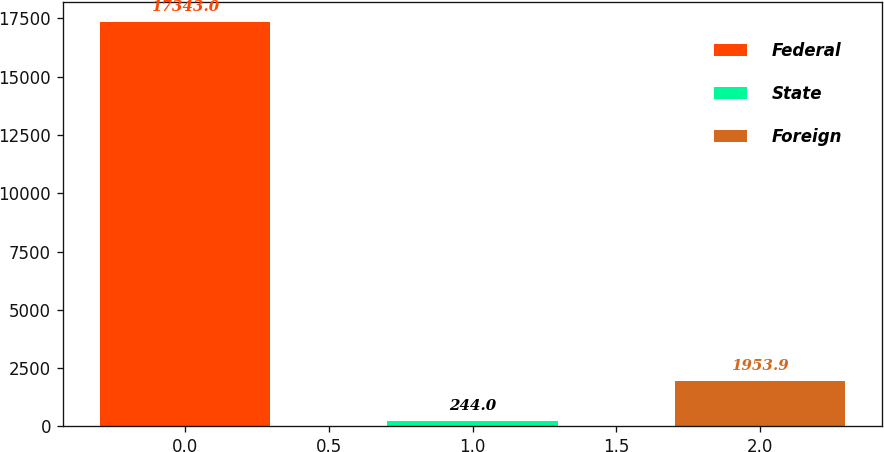<chart> <loc_0><loc_0><loc_500><loc_500><bar_chart><fcel>Federal<fcel>State<fcel>Foreign<nl><fcel>17343<fcel>244<fcel>1953.9<nl></chart> 